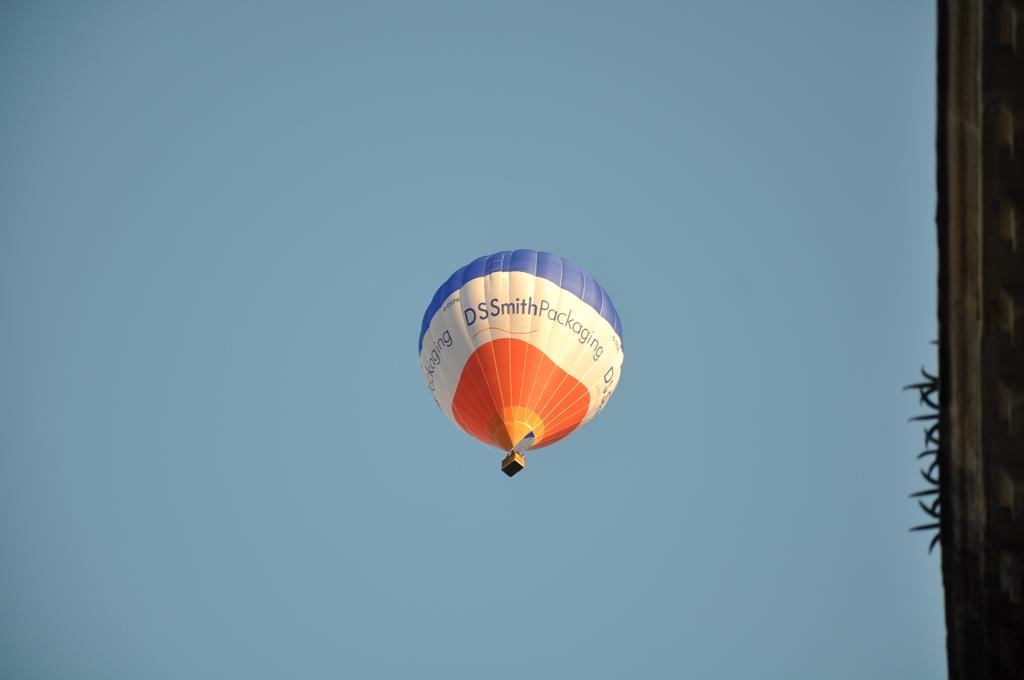<image>
Relay a brief, clear account of the picture shown. A hot air balloon is in the sky and says DSSmithPackaging on it. 